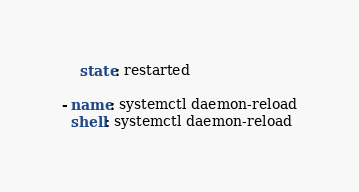<code> <loc_0><loc_0><loc_500><loc_500><_YAML_>    state: restarted

- name: systemctl daemon-reload
  shell: systemctl daemon-reload</code> 